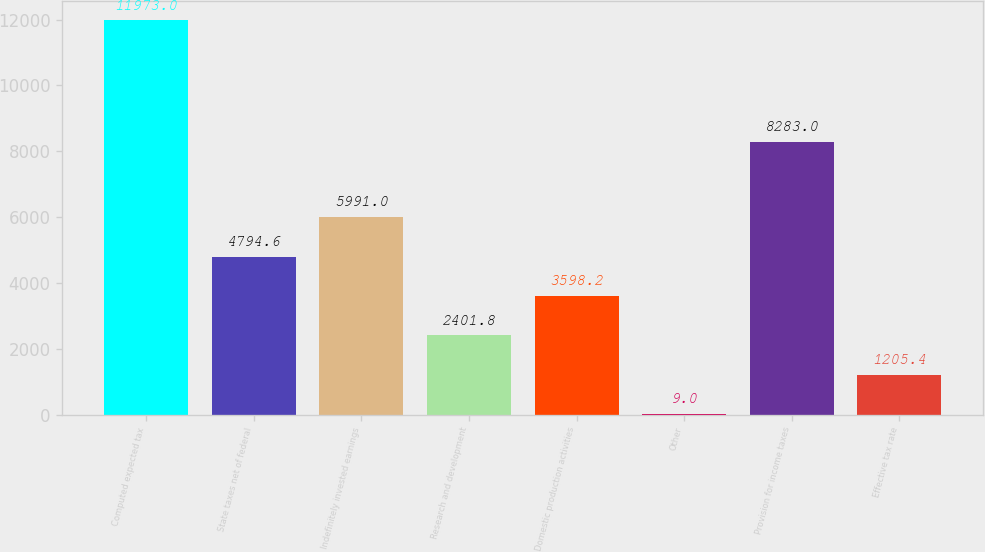<chart> <loc_0><loc_0><loc_500><loc_500><bar_chart><fcel>Computed expected tax<fcel>State taxes net of federal<fcel>Indefinitely invested earnings<fcel>Research and development<fcel>Domestic production activities<fcel>Other<fcel>Provision for income taxes<fcel>Effective tax rate<nl><fcel>11973<fcel>4794.6<fcel>5991<fcel>2401.8<fcel>3598.2<fcel>9<fcel>8283<fcel>1205.4<nl></chart> 